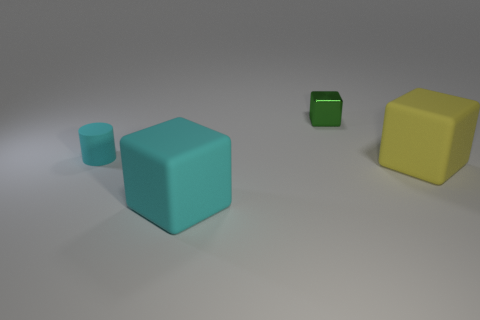There is a big thing that is the same color as the small rubber cylinder; what is its shape?
Offer a very short reply. Cube. How many objects are to the left of the tiny green cube and in front of the matte cylinder?
Your response must be concise. 1. What is the size of the green thing that is the same shape as the large cyan matte object?
Your answer should be very brief. Small. How many large objects are made of the same material as the big yellow cube?
Ensure brevity in your answer.  1. Are there fewer green shiny cubes left of the green metal block than cyan cubes?
Your answer should be compact. Yes. How many tiny objects are there?
Your response must be concise. 2. What number of big rubber objects have the same color as the tiny cylinder?
Make the answer very short. 1. Do the small rubber object and the yellow thing have the same shape?
Ensure brevity in your answer.  No. There is a matte block in front of the rubber cube behind the big cyan block; what size is it?
Provide a succinct answer. Large. Is there a green metal block of the same size as the cylinder?
Your response must be concise. Yes. 